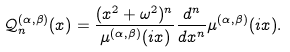<formula> <loc_0><loc_0><loc_500><loc_500>\mathcal { Q } ^ { ( \alpha , \beta ) } _ { n } ( x ) = \frac { ( x ^ { 2 } + \omega ^ { 2 } ) ^ { n } } { \mu ^ { ( \alpha , \beta ) } ( i x ) } \frac { d ^ { n } } { d x ^ { n } } \mu ^ { ( \alpha , \beta ) } ( i x ) .</formula> 